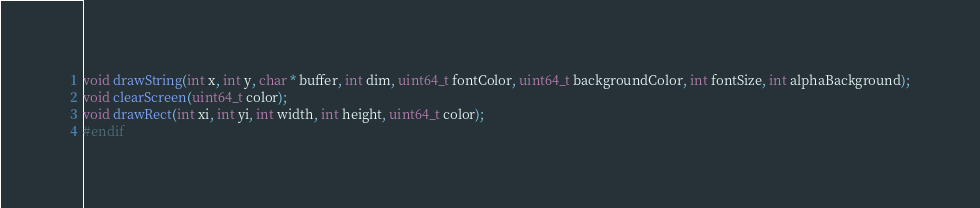Convert code to text. <code><loc_0><loc_0><loc_500><loc_500><_C_>
void drawString(int x, int y, char * buffer, int dim, uint64_t fontColor, uint64_t backgroundColor, int fontSize, int alphaBackground);
void clearScreen(uint64_t color);
void drawRect(int xi, int yi, int width, int height, uint64_t color);
#endif
</code> 